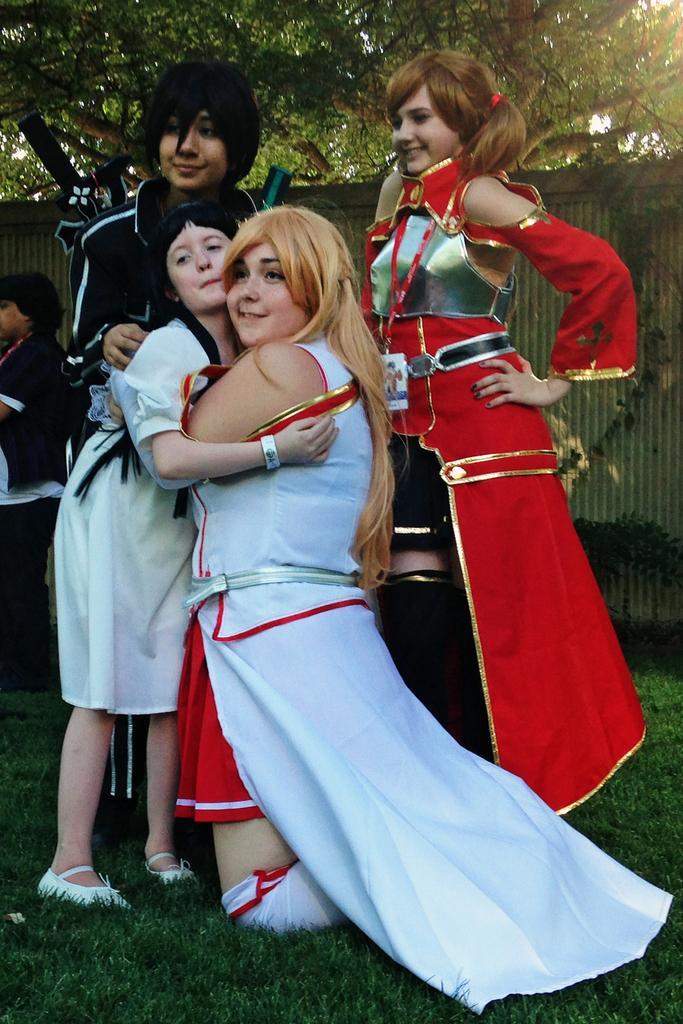Can you describe this image briefly? Here in this picture we can see a group of women and a child in a cosplay present on the ground, which is fully covered with grass and we can see all of them are smiling and behind them also we can see other person standing and we can see plants and trees present and we can also see a shed present. 